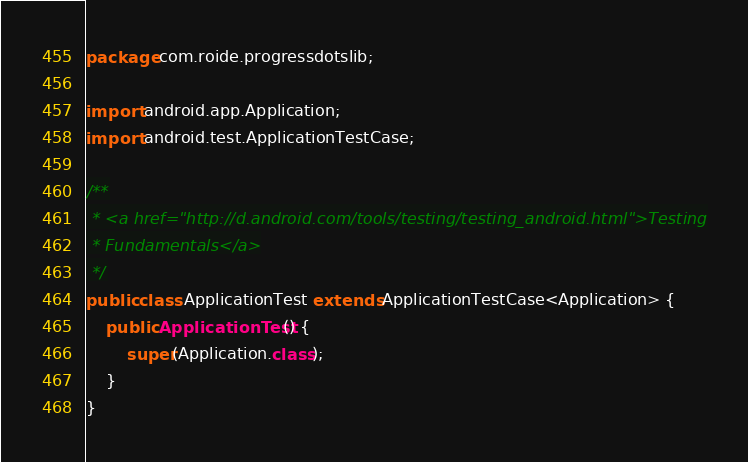Convert code to text. <code><loc_0><loc_0><loc_500><loc_500><_Java_>package com.roide.progressdotslib;

import android.app.Application;
import android.test.ApplicationTestCase;

/**
 * <a href="http://d.android.com/tools/testing/testing_android.html">Testing
 * Fundamentals</a>
 */
public class ApplicationTest extends ApplicationTestCase<Application> {
    public ApplicationTest() {
        super(Application.class);
    }
}</code> 